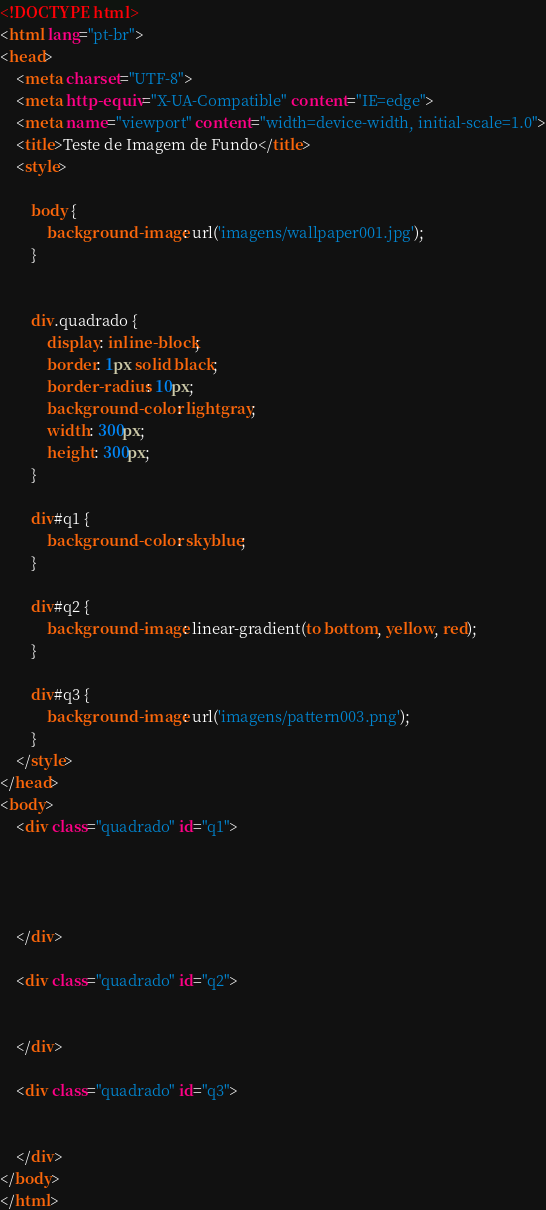<code> <loc_0><loc_0><loc_500><loc_500><_HTML_><!DOCTYPE html>
<html lang="pt-br">
<head>
    <meta charset="UTF-8">
    <meta http-equiv="X-UA-Compatible" content="IE=edge">
    <meta name="viewport" content="width=device-width, initial-scale=1.0">
    <title>Teste de Imagem de Fundo</title>
    <style>

        body {
            background-image: url('imagens/wallpaper001.jpg');
        }


        div.quadrado {
            display: inline-block;
            border: 1px solid black;
            border-radius: 10px;
            background-color: lightgray;
            width: 300px;
            height: 300px;
        }

        div#q1 {
            background-color: skyblue;
        }

        div#q2 {
            background-image: linear-gradient(to bottom, yellow, red);
        }

        div#q3 {
            background-image: url('imagens/pattern003.png');
        }
    </style>
</head>
<body>
    <div class="quadrado" id="q1">




    </div>

    <div class="quadrado" id="q2">


    </div>

    <div class="quadrado" id="q3">


    </div>
</body>
</html></code> 